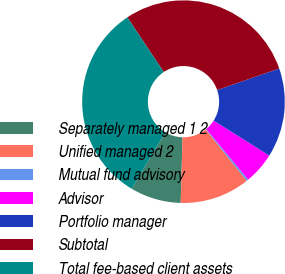<chart> <loc_0><loc_0><loc_500><loc_500><pie_chart><fcel>Separately managed 1 2<fcel>Unified managed 2<fcel>Mutual fund advisory<fcel>Advisor<fcel>Portfolio manager<fcel>Subtotal<fcel>Total fee-based client assets<nl><fcel>8.1%<fcel>11.17%<fcel>0.3%<fcel>5.04%<fcel>14.24%<fcel>29.04%<fcel>32.11%<nl></chart> 